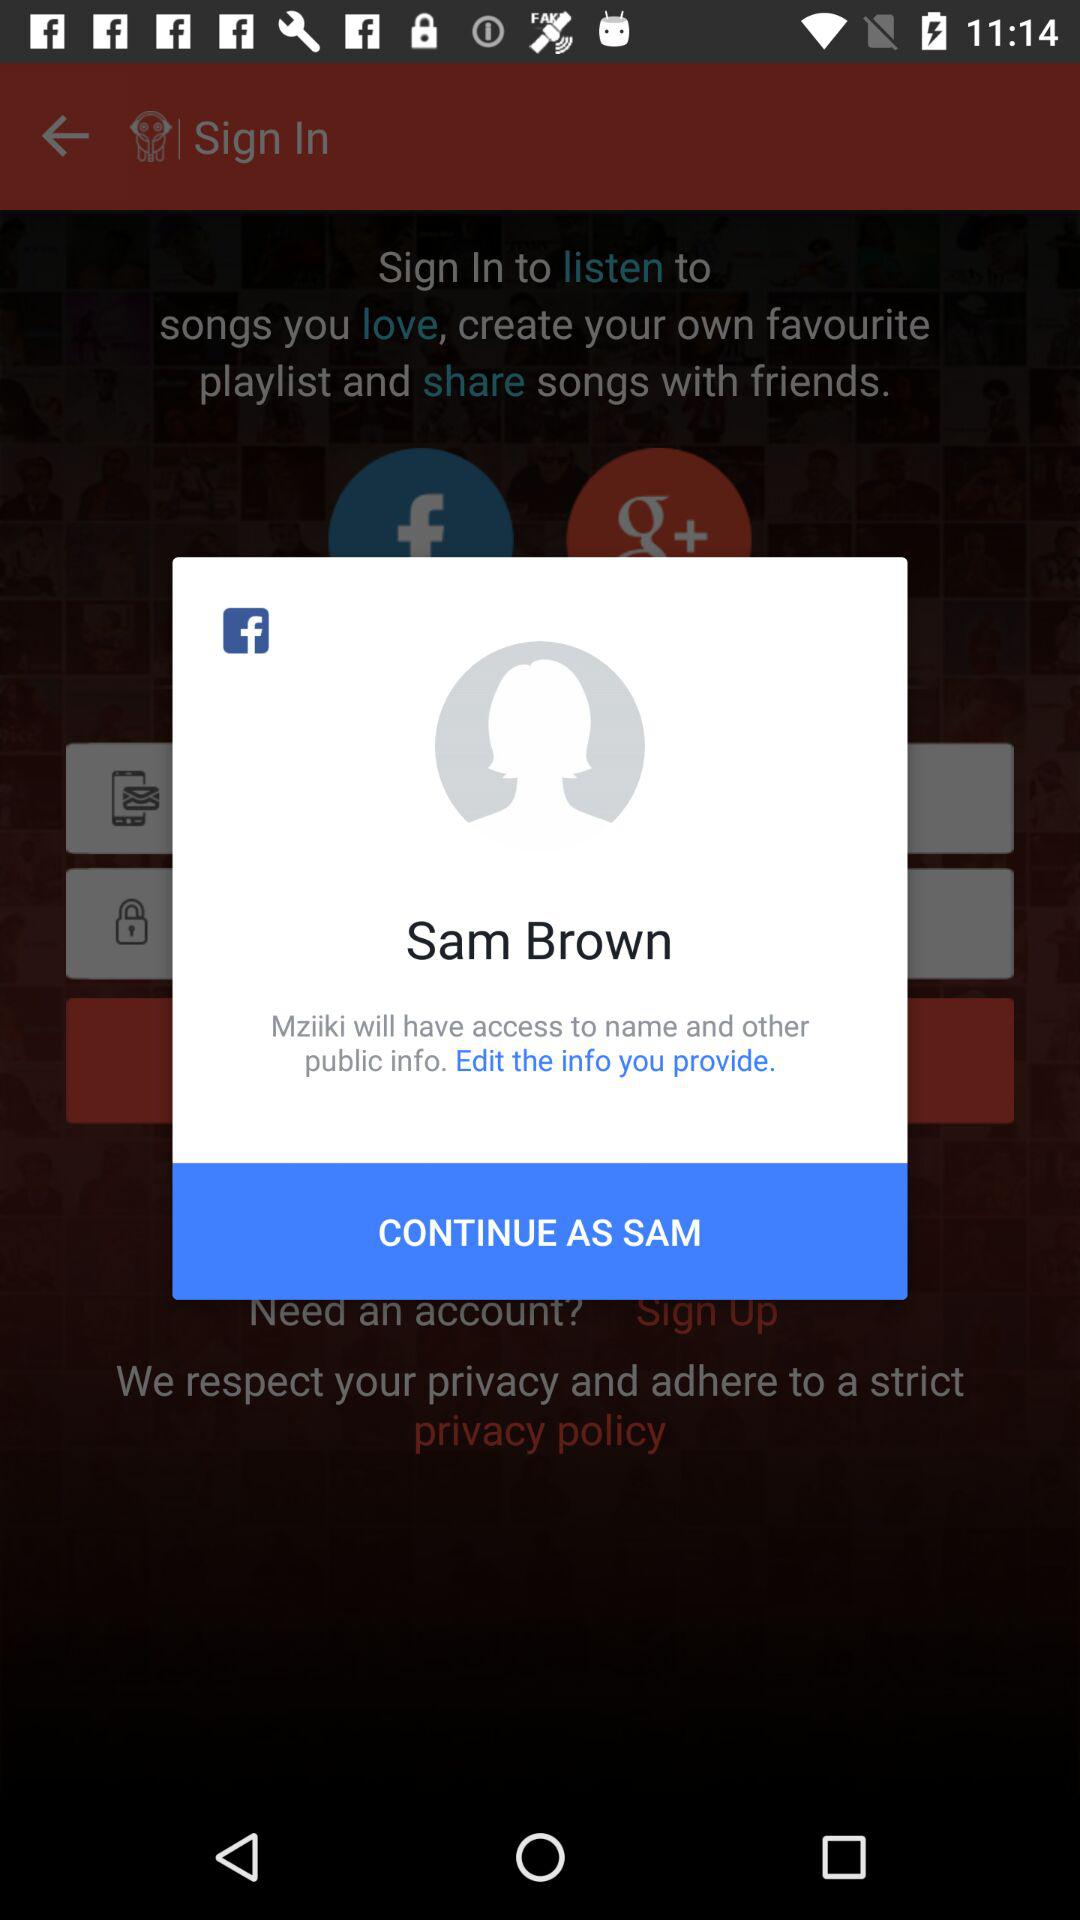What application will have access to the name and other public info.? The application "Mziiki" will have access to the name and other public info. 